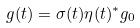Convert formula to latex. <formula><loc_0><loc_0><loc_500><loc_500>g ( t ) = \sigma ( t ) \eta ( t ) ^ { * } g _ { 0 }</formula> 